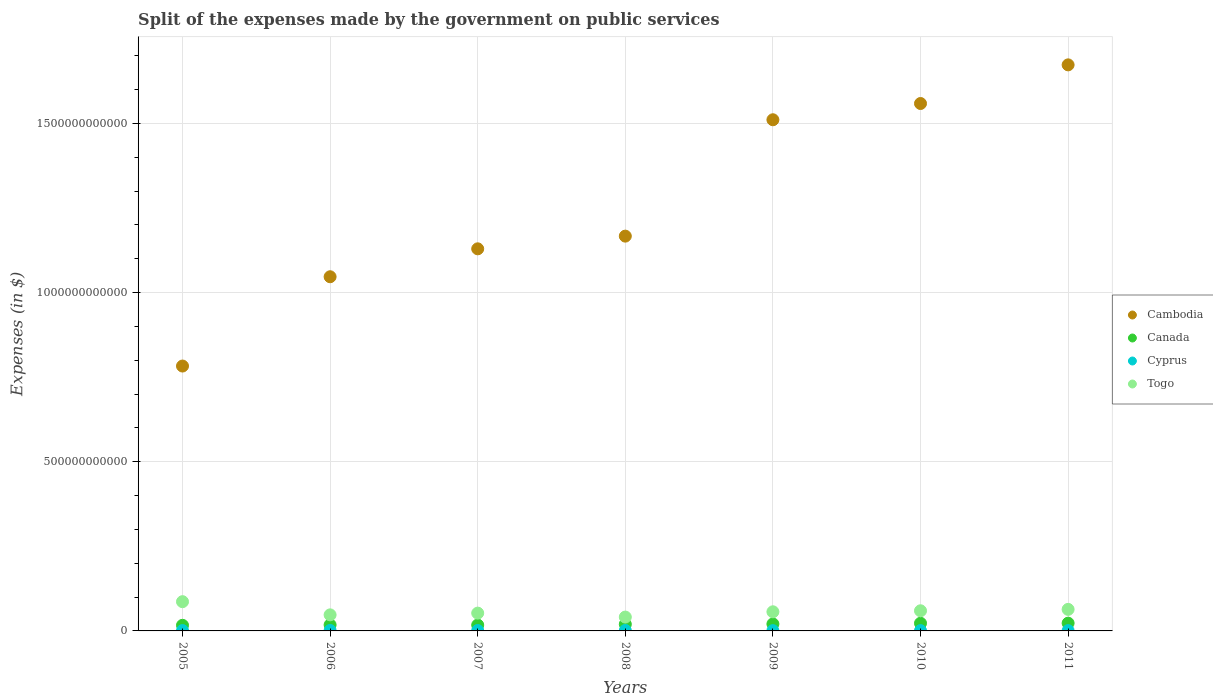Is the number of dotlines equal to the number of legend labels?
Offer a very short reply. Yes. What is the expenses made by the government on public services in Cyprus in 2010?
Make the answer very short. 8.91e+08. Across all years, what is the maximum expenses made by the government on public services in Canada?
Your response must be concise. 2.29e+1. Across all years, what is the minimum expenses made by the government on public services in Cambodia?
Offer a terse response. 7.83e+11. What is the total expenses made by the government on public services in Cambodia in the graph?
Make the answer very short. 8.87e+12. What is the difference between the expenses made by the government on public services in Cyprus in 2005 and that in 2006?
Keep it short and to the point. -2.13e+08. What is the difference between the expenses made by the government on public services in Canada in 2006 and the expenses made by the government on public services in Cyprus in 2005?
Your answer should be very brief. 1.68e+1. What is the average expenses made by the government on public services in Cambodia per year?
Offer a very short reply. 1.27e+12. In the year 2009, what is the difference between the expenses made by the government on public services in Togo and expenses made by the government on public services in Canada?
Ensure brevity in your answer.  3.60e+1. What is the ratio of the expenses made by the government on public services in Togo in 2006 to that in 2009?
Provide a succinct answer. 0.84. Is the expenses made by the government on public services in Togo in 2008 less than that in 2009?
Provide a succinct answer. Yes. What is the difference between the highest and the second highest expenses made by the government on public services in Cyprus?
Offer a terse response. 7.07e+07. What is the difference between the highest and the lowest expenses made by the government on public services in Canada?
Your answer should be compact. 6.34e+09. In how many years, is the expenses made by the government on public services in Cambodia greater than the average expenses made by the government on public services in Cambodia taken over all years?
Your answer should be compact. 3. Does the expenses made by the government on public services in Cyprus monotonically increase over the years?
Your answer should be compact. No. How many years are there in the graph?
Provide a succinct answer. 7. What is the difference between two consecutive major ticks on the Y-axis?
Give a very brief answer. 5.00e+11. Does the graph contain grids?
Offer a terse response. Yes. How many legend labels are there?
Your response must be concise. 4. How are the legend labels stacked?
Offer a very short reply. Vertical. What is the title of the graph?
Your response must be concise. Split of the expenses made by the government on public services. Does "Upper middle income" appear as one of the legend labels in the graph?
Offer a very short reply. No. What is the label or title of the Y-axis?
Provide a short and direct response. Expenses (in $). What is the Expenses (in $) in Cambodia in 2005?
Your answer should be very brief. 7.83e+11. What is the Expenses (in $) in Canada in 2005?
Your answer should be very brief. 1.66e+1. What is the Expenses (in $) in Cyprus in 2005?
Offer a very short reply. 1.05e+09. What is the Expenses (in $) of Togo in 2005?
Your response must be concise. 8.64e+1. What is the Expenses (in $) of Cambodia in 2006?
Give a very brief answer. 1.05e+12. What is the Expenses (in $) of Canada in 2006?
Ensure brevity in your answer.  1.79e+1. What is the Expenses (in $) of Cyprus in 2006?
Offer a very short reply. 1.26e+09. What is the Expenses (in $) of Togo in 2006?
Provide a succinct answer. 4.75e+1. What is the Expenses (in $) in Cambodia in 2007?
Your answer should be very brief. 1.13e+12. What is the Expenses (in $) in Canada in 2007?
Give a very brief answer. 1.74e+1. What is the Expenses (in $) in Cyprus in 2007?
Your response must be concise. 1.17e+09. What is the Expenses (in $) of Togo in 2007?
Give a very brief answer. 5.26e+1. What is the Expenses (in $) of Cambodia in 2008?
Your response must be concise. 1.17e+12. What is the Expenses (in $) of Canada in 2008?
Provide a short and direct response. 1.97e+1. What is the Expenses (in $) of Cyprus in 2008?
Provide a succinct answer. 1.33e+09. What is the Expenses (in $) of Togo in 2008?
Provide a succinct answer. 4.09e+1. What is the Expenses (in $) of Cambodia in 2009?
Your response must be concise. 1.51e+12. What is the Expenses (in $) in Canada in 2009?
Ensure brevity in your answer.  2.05e+1. What is the Expenses (in $) of Cyprus in 2009?
Make the answer very short. 8.23e+08. What is the Expenses (in $) in Togo in 2009?
Give a very brief answer. 5.65e+1. What is the Expenses (in $) in Cambodia in 2010?
Your answer should be very brief. 1.56e+12. What is the Expenses (in $) of Canada in 2010?
Keep it short and to the point. 2.27e+1. What is the Expenses (in $) in Cyprus in 2010?
Provide a succinct answer. 8.91e+08. What is the Expenses (in $) of Togo in 2010?
Offer a very short reply. 5.95e+1. What is the Expenses (in $) of Cambodia in 2011?
Provide a short and direct response. 1.67e+12. What is the Expenses (in $) of Canada in 2011?
Provide a short and direct response. 2.29e+1. What is the Expenses (in $) in Cyprus in 2011?
Your answer should be compact. 8.55e+08. What is the Expenses (in $) of Togo in 2011?
Provide a succinct answer. 6.37e+1. Across all years, what is the maximum Expenses (in $) of Cambodia?
Keep it short and to the point. 1.67e+12. Across all years, what is the maximum Expenses (in $) of Canada?
Keep it short and to the point. 2.29e+1. Across all years, what is the maximum Expenses (in $) in Cyprus?
Offer a terse response. 1.33e+09. Across all years, what is the maximum Expenses (in $) of Togo?
Your response must be concise. 8.64e+1. Across all years, what is the minimum Expenses (in $) in Cambodia?
Offer a terse response. 7.83e+11. Across all years, what is the minimum Expenses (in $) in Canada?
Provide a short and direct response. 1.66e+1. Across all years, what is the minimum Expenses (in $) in Cyprus?
Ensure brevity in your answer.  8.23e+08. Across all years, what is the minimum Expenses (in $) in Togo?
Your answer should be compact. 4.09e+1. What is the total Expenses (in $) of Cambodia in the graph?
Offer a very short reply. 8.87e+12. What is the total Expenses (in $) in Canada in the graph?
Offer a terse response. 1.38e+11. What is the total Expenses (in $) of Cyprus in the graph?
Your answer should be compact. 7.39e+09. What is the total Expenses (in $) of Togo in the graph?
Offer a very short reply. 4.07e+11. What is the difference between the Expenses (in $) of Cambodia in 2005 and that in 2006?
Provide a short and direct response. -2.64e+11. What is the difference between the Expenses (in $) in Canada in 2005 and that in 2006?
Provide a short and direct response. -1.26e+09. What is the difference between the Expenses (in $) of Cyprus in 2005 and that in 2006?
Give a very brief answer. -2.13e+08. What is the difference between the Expenses (in $) in Togo in 2005 and that in 2006?
Provide a short and direct response. 3.90e+1. What is the difference between the Expenses (in $) in Cambodia in 2005 and that in 2007?
Your response must be concise. -3.46e+11. What is the difference between the Expenses (in $) in Canada in 2005 and that in 2007?
Offer a very short reply. -7.98e+08. What is the difference between the Expenses (in $) in Cyprus in 2005 and that in 2007?
Ensure brevity in your answer.  -1.21e+08. What is the difference between the Expenses (in $) in Togo in 2005 and that in 2007?
Offer a terse response. 3.38e+1. What is the difference between the Expenses (in $) of Cambodia in 2005 and that in 2008?
Your answer should be very brief. -3.84e+11. What is the difference between the Expenses (in $) in Canada in 2005 and that in 2008?
Keep it short and to the point. -3.12e+09. What is the difference between the Expenses (in $) of Cyprus in 2005 and that in 2008?
Keep it short and to the point. -2.83e+08. What is the difference between the Expenses (in $) in Togo in 2005 and that in 2008?
Offer a very short reply. 4.55e+1. What is the difference between the Expenses (in $) of Cambodia in 2005 and that in 2009?
Keep it short and to the point. -7.28e+11. What is the difference between the Expenses (in $) of Canada in 2005 and that in 2009?
Your answer should be very brief. -3.93e+09. What is the difference between the Expenses (in $) in Cyprus in 2005 and that in 2009?
Keep it short and to the point. 2.27e+08. What is the difference between the Expenses (in $) in Togo in 2005 and that in 2009?
Make the answer very short. 2.99e+1. What is the difference between the Expenses (in $) of Cambodia in 2005 and that in 2010?
Your answer should be compact. -7.76e+11. What is the difference between the Expenses (in $) of Canada in 2005 and that in 2010?
Offer a very short reply. -6.07e+09. What is the difference between the Expenses (in $) of Cyprus in 2005 and that in 2010?
Offer a very short reply. 1.60e+08. What is the difference between the Expenses (in $) of Togo in 2005 and that in 2010?
Give a very brief answer. 2.69e+1. What is the difference between the Expenses (in $) of Cambodia in 2005 and that in 2011?
Your answer should be very brief. -8.90e+11. What is the difference between the Expenses (in $) of Canada in 2005 and that in 2011?
Your answer should be compact. -6.34e+09. What is the difference between the Expenses (in $) of Cyprus in 2005 and that in 2011?
Your response must be concise. 1.95e+08. What is the difference between the Expenses (in $) in Togo in 2005 and that in 2011?
Make the answer very short. 2.28e+1. What is the difference between the Expenses (in $) of Cambodia in 2006 and that in 2007?
Your response must be concise. -8.25e+1. What is the difference between the Expenses (in $) of Canada in 2006 and that in 2007?
Your answer should be very brief. 4.67e+08. What is the difference between the Expenses (in $) of Cyprus in 2006 and that in 2007?
Your response must be concise. 9.14e+07. What is the difference between the Expenses (in $) in Togo in 2006 and that in 2007?
Offer a very short reply. -5.13e+09. What is the difference between the Expenses (in $) in Cambodia in 2006 and that in 2008?
Your answer should be very brief. -1.20e+11. What is the difference between the Expenses (in $) in Canada in 2006 and that in 2008?
Keep it short and to the point. -1.85e+09. What is the difference between the Expenses (in $) in Cyprus in 2006 and that in 2008?
Give a very brief answer. -7.07e+07. What is the difference between the Expenses (in $) of Togo in 2006 and that in 2008?
Provide a succinct answer. 6.54e+09. What is the difference between the Expenses (in $) in Cambodia in 2006 and that in 2009?
Ensure brevity in your answer.  -4.64e+11. What is the difference between the Expenses (in $) of Canada in 2006 and that in 2009?
Offer a terse response. -2.66e+09. What is the difference between the Expenses (in $) of Cyprus in 2006 and that in 2009?
Provide a succinct answer. 4.40e+08. What is the difference between the Expenses (in $) in Togo in 2006 and that in 2009?
Your answer should be very brief. -9.06e+09. What is the difference between the Expenses (in $) in Cambodia in 2006 and that in 2010?
Provide a succinct answer. -5.12e+11. What is the difference between the Expenses (in $) in Canada in 2006 and that in 2010?
Keep it short and to the point. -4.80e+09. What is the difference between the Expenses (in $) in Cyprus in 2006 and that in 2010?
Ensure brevity in your answer.  3.72e+08. What is the difference between the Expenses (in $) in Togo in 2006 and that in 2010?
Provide a short and direct response. -1.21e+1. What is the difference between the Expenses (in $) of Cambodia in 2006 and that in 2011?
Ensure brevity in your answer.  -6.26e+11. What is the difference between the Expenses (in $) of Canada in 2006 and that in 2011?
Your answer should be very brief. -5.07e+09. What is the difference between the Expenses (in $) in Cyprus in 2006 and that in 2011?
Provide a succinct answer. 4.08e+08. What is the difference between the Expenses (in $) in Togo in 2006 and that in 2011?
Provide a succinct answer. -1.62e+1. What is the difference between the Expenses (in $) in Cambodia in 2007 and that in 2008?
Your response must be concise. -3.75e+1. What is the difference between the Expenses (in $) of Canada in 2007 and that in 2008?
Your response must be concise. -2.32e+09. What is the difference between the Expenses (in $) of Cyprus in 2007 and that in 2008?
Ensure brevity in your answer.  -1.62e+08. What is the difference between the Expenses (in $) of Togo in 2007 and that in 2008?
Your answer should be very brief. 1.17e+1. What is the difference between the Expenses (in $) of Cambodia in 2007 and that in 2009?
Ensure brevity in your answer.  -3.81e+11. What is the difference between the Expenses (in $) in Canada in 2007 and that in 2009?
Keep it short and to the point. -3.13e+09. What is the difference between the Expenses (in $) in Cyprus in 2007 and that in 2009?
Your answer should be very brief. 3.48e+08. What is the difference between the Expenses (in $) of Togo in 2007 and that in 2009?
Your answer should be very brief. -3.92e+09. What is the difference between the Expenses (in $) of Cambodia in 2007 and that in 2010?
Offer a terse response. -4.30e+11. What is the difference between the Expenses (in $) in Canada in 2007 and that in 2010?
Offer a terse response. -5.27e+09. What is the difference between the Expenses (in $) in Cyprus in 2007 and that in 2010?
Your answer should be very brief. 2.81e+08. What is the difference between the Expenses (in $) of Togo in 2007 and that in 2010?
Offer a terse response. -6.92e+09. What is the difference between the Expenses (in $) in Cambodia in 2007 and that in 2011?
Offer a terse response. -5.44e+11. What is the difference between the Expenses (in $) in Canada in 2007 and that in 2011?
Make the answer very short. -5.54e+09. What is the difference between the Expenses (in $) in Cyprus in 2007 and that in 2011?
Your answer should be very brief. 3.16e+08. What is the difference between the Expenses (in $) in Togo in 2007 and that in 2011?
Make the answer very short. -1.11e+1. What is the difference between the Expenses (in $) in Cambodia in 2008 and that in 2009?
Your response must be concise. -3.44e+11. What is the difference between the Expenses (in $) in Canada in 2008 and that in 2009?
Provide a short and direct response. -8.08e+08. What is the difference between the Expenses (in $) in Cyprus in 2008 and that in 2009?
Keep it short and to the point. 5.10e+08. What is the difference between the Expenses (in $) in Togo in 2008 and that in 2009?
Ensure brevity in your answer.  -1.56e+1. What is the difference between the Expenses (in $) of Cambodia in 2008 and that in 2010?
Give a very brief answer. -3.92e+11. What is the difference between the Expenses (in $) of Canada in 2008 and that in 2010?
Provide a short and direct response. -2.95e+09. What is the difference between the Expenses (in $) in Cyprus in 2008 and that in 2010?
Ensure brevity in your answer.  4.43e+08. What is the difference between the Expenses (in $) in Togo in 2008 and that in 2010?
Your answer should be very brief. -1.86e+1. What is the difference between the Expenses (in $) in Cambodia in 2008 and that in 2011?
Your answer should be compact. -5.06e+11. What is the difference between the Expenses (in $) in Canada in 2008 and that in 2011?
Your response must be concise. -3.22e+09. What is the difference between the Expenses (in $) of Cyprus in 2008 and that in 2011?
Provide a succinct answer. 4.79e+08. What is the difference between the Expenses (in $) in Togo in 2008 and that in 2011?
Ensure brevity in your answer.  -2.27e+1. What is the difference between the Expenses (in $) in Cambodia in 2009 and that in 2010?
Offer a terse response. -4.80e+1. What is the difference between the Expenses (in $) in Canada in 2009 and that in 2010?
Give a very brief answer. -2.14e+09. What is the difference between the Expenses (in $) in Cyprus in 2009 and that in 2010?
Make the answer very short. -6.76e+07. What is the difference between the Expenses (in $) in Togo in 2009 and that in 2010?
Offer a terse response. -2.99e+09. What is the difference between the Expenses (in $) of Cambodia in 2009 and that in 2011?
Offer a terse response. -1.62e+11. What is the difference between the Expenses (in $) in Canada in 2009 and that in 2011?
Keep it short and to the point. -2.41e+09. What is the difference between the Expenses (in $) of Cyprus in 2009 and that in 2011?
Offer a terse response. -3.18e+07. What is the difference between the Expenses (in $) in Togo in 2009 and that in 2011?
Your answer should be compact. -7.14e+09. What is the difference between the Expenses (in $) in Cambodia in 2010 and that in 2011?
Offer a very short reply. -1.14e+11. What is the difference between the Expenses (in $) of Canada in 2010 and that in 2011?
Ensure brevity in your answer.  -2.67e+08. What is the difference between the Expenses (in $) in Cyprus in 2010 and that in 2011?
Ensure brevity in your answer.  3.58e+07. What is the difference between the Expenses (in $) in Togo in 2010 and that in 2011?
Keep it short and to the point. -4.14e+09. What is the difference between the Expenses (in $) in Cambodia in 2005 and the Expenses (in $) in Canada in 2006?
Give a very brief answer. 7.65e+11. What is the difference between the Expenses (in $) of Cambodia in 2005 and the Expenses (in $) of Cyprus in 2006?
Offer a very short reply. 7.82e+11. What is the difference between the Expenses (in $) of Cambodia in 2005 and the Expenses (in $) of Togo in 2006?
Your answer should be very brief. 7.35e+11. What is the difference between the Expenses (in $) of Canada in 2005 and the Expenses (in $) of Cyprus in 2006?
Ensure brevity in your answer.  1.53e+1. What is the difference between the Expenses (in $) in Canada in 2005 and the Expenses (in $) in Togo in 2006?
Provide a succinct answer. -3.09e+1. What is the difference between the Expenses (in $) in Cyprus in 2005 and the Expenses (in $) in Togo in 2006?
Offer a terse response. -4.64e+1. What is the difference between the Expenses (in $) in Cambodia in 2005 and the Expenses (in $) in Canada in 2007?
Keep it short and to the point. 7.66e+11. What is the difference between the Expenses (in $) of Cambodia in 2005 and the Expenses (in $) of Cyprus in 2007?
Make the answer very short. 7.82e+11. What is the difference between the Expenses (in $) in Cambodia in 2005 and the Expenses (in $) in Togo in 2007?
Offer a terse response. 7.30e+11. What is the difference between the Expenses (in $) in Canada in 2005 and the Expenses (in $) in Cyprus in 2007?
Your answer should be compact. 1.54e+1. What is the difference between the Expenses (in $) of Canada in 2005 and the Expenses (in $) of Togo in 2007?
Make the answer very short. -3.60e+1. What is the difference between the Expenses (in $) in Cyprus in 2005 and the Expenses (in $) in Togo in 2007?
Make the answer very short. -5.16e+1. What is the difference between the Expenses (in $) in Cambodia in 2005 and the Expenses (in $) in Canada in 2008?
Keep it short and to the point. 7.63e+11. What is the difference between the Expenses (in $) of Cambodia in 2005 and the Expenses (in $) of Cyprus in 2008?
Your answer should be very brief. 7.82e+11. What is the difference between the Expenses (in $) of Cambodia in 2005 and the Expenses (in $) of Togo in 2008?
Your answer should be very brief. 7.42e+11. What is the difference between the Expenses (in $) in Canada in 2005 and the Expenses (in $) in Cyprus in 2008?
Offer a very short reply. 1.53e+1. What is the difference between the Expenses (in $) of Canada in 2005 and the Expenses (in $) of Togo in 2008?
Offer a very short reply. -2.43e+1. What is the difference between the Expenses (in $) of Cyprus in 2005 and the Expenses (in $) of Togo in 2008?
Ensure brevity in your answer.  -3.99e+1. What is the difference between the Expenses (in $) of Cambodia in 2005 and the Expenses (in $) of Canada in 2009?
Your response must be concise. 7.62e+11. What is the difference between the Expenses (in $) of Cambodia in 2005 and the Expenses (in $) of Cyprus in 2009?
Offer a very short reply. 7.82e+11. What is the difference between the Expenses (in $) of Cambodia in 2005 and the Expenses (in $) of Togo in 2009?
Your answer should be very brief. 7.26e+11. What is the difference between the Expenses (in $) in Canada in 2005 and the Expenses (in $) in Cyprus in 2009?
Provide a succinct answer. 1.58e+1. What is the difference between the Expenses (in $) of Canada in 2005 and the Expenses (in $) of Togo in 2009?
Provide a succinct answer. -3.99e+1. What is the difference between the Expenses (in $) of Cyprus in 2005 and the Expenses (in $) of Togo in 2009?
Give a very brief answer. -5.55e+1. What is the difference between the Expenses (in $) in Cambodia in 2005 and the Expenses (in $) in Canada in 2010?
Provide a short and direct response. 7.60e+11. What is the difference between the Expenses (in $) of Cambodia in 2005 and the Expenses (in $) of Cyprus in 2010?
Keep it short and to the point. 7.82e+11. What is the difference between the Expenses (in $) of Cambodia in 2005 and the Expenses (in $) of Togo in 2010?
Your response must be concise. 7.23e+11. What is the difference between the Expenses (in $) of Canada in 2005 and the Expenses (in $) of Cyprus in 2010?
Make the answer very short. 1.57e+1. What is the difference between the Expenses (in $) in Canada in 2005 and the Expenses (in $) in Togo in 2010?
Provide a short and direct response. -4.29e+1. What is the difference between the Expenses (in $) of Cyprus in 2005 and the Expenses (in $) of Togo in 2010?
Ensure brevity in your answer.  -5.85e+1. What is the difference between the Expenses (in $) of Cambodia in 2005 and the Expenses (in $) of Canada in 2011?
Give a very brief answer. 7.60e+11. What is the difference between the Expenses (in $) of Cambodia in 2005 and the Expenses (in $) of Cyprus in 2011?
Ensure brevity in your answer.  7.82e+11. What is the difference between the Expenses (in $) of Cambodia in 2005 and the Expenses (in $) of Togo in 2011?
Offer a terse response. 7.19e+11. What is the difference between the Expenses (in $) of Canada in 2005 and the Expenses (in $) of Cyprus in 2011?
Make the answer very short. 1.57e+1. What is the difference between the Expenses (in $) of Canada in 2005 and the Expenses (in $) of Togo in 2011?
Your response must be concise. -4.71e+1. What is the difference between the Expenses (in $) of Cyprus in 2005 and the Expenses (in $) of Togo in 2011?
Provide a short and direct response. -6.26e+1. What is the difference between the Expenses (in $) of Cambodia in 2006 and the Expenses (in $) of Canada in 2007?
Provide a succinct answer. 1.03e+12. What is the difference between the Expenses (in $) in Cambodia in 2006 and the Expenses (in $) in Cyprus in 2007?
Offer a terse response. 1.05e+12. What is the difference between the Expenses (in $) of Cambodia in 2006 and the Expenses (in $) of Togo in 2007?
Your answer should be very brief. 9.94e+11. What is the difference between the Expenses (in $) of Canada in 2006 and the Expenses (in $) of Cyprus in 2007?
Offer a very short reply. 1.67e+1. What is the difference between the Expenses (in $) of Canada in 2006 and the Expenses (in $) of Togo in 2007?
Offer a terse response. -3.48e+1. What is the difference between the Expenses (in $) of Cyprus in 2006 and the Expenses (in $) of Togo in 2007?
Ensure brevity in your answer.  -5.14e+1. What is the difference between the Expenses (in $) of Cambodia in 2006 and the Expenses (in $) of Canada in 2008?
Your response must be concise. 1.03e+12. What is the difference between the Expenses (in $) of Cambodia in 2006 and the Expenses (in $) of Cyprus in 2008?
Provide a succinct answer. 1.05e+12. What is the difference between the Expenses (in $) of Cambodia in 2006 and the Expenses (in $) of Togo in 2008?
Offer a very short reply. 1.01e+12. What is the difference between the Expenses (in $) in Canada in 2006 and the Expenses (in $) in Cyprus in 2008?
Your answer should be compact. 1.65e+1. What is the difference between the Expenses (in $) of Canada in 2006 and the Expenses (in $) of Togo in 2008?
Provide a succinct answer. -2.31e+1. What is the difference between the Expenses (in $) in Cyprus in 2006 and the Expenses (in $) in Togo in 2008?
Provide a succinct answer. -3.97e+1. What is the difference between the Expenses (in $) of Cambodia in 2006 and the Expenses (in $) of Canada in 2009?
Ensure brevity in your answer.  1.03e+12. What is the difference between the Expenses (in $) of Cambodia in 2006 and the Expenses (in $) of Cyprus in 2009?
Provide a succinct answer. 1.05e+12. What is the difference between the Expenses (in $) of Cambodia in 2006 and the Expenses (in $) of Togo in 2009?
Your response must be concise. 9.90e+11. What is the difference between the Expenses (in $) in Canada in 2006 and the Expenses (in $) in Cyprus in 2009?
Your answer should be very brief. 1.70e+1. What is the difference between the Expenses (in $) in Canada in 2006 and the Expenses (in $) in Togo in 2009?
Ensure brevity in your answer.  -3.87e+1. What is the difference between the Expenses (in $) of Cyprus in 2006 and the Expenses (in $) of Togo in 2009?
Give a very brief answer. -5.53e+1. What is the difference between the Expenses (in $) in Cambodia in 2006 and the Expenses (in $) in Canada in 2010?
Make the answer very short. 1.02e+12. What is the difference between the Expenses (in $) of Cambodia in 2006 and the Expenses (in $) of Cyprus in 2010?
Offer a very short reply. 1.05e+12. What is the difference between the Expenses (in $) of Cambodia in 2006 and the Expenses (in $) of Togo in 2010?
Your answer should be very brief. 9.87e+11. What is the difference between the Expenses (in $) of Canada in 2006 and the Expenses (in $) of Cyprus in 2010?
Your response must be concise. 1.70e+1. What is the difference between the Expenses (in $) of Canada in 2006 and the Expenses (in $) of Togo in 2010?
Your answer should be compact. -4.17e+1. What is the difference between the Expenses (in $) in Cyprus in 2006 and the Expenses (in $) in Togo in 2010?
Provide a succinct answer. -5.83e+1. What is the difference between the Expenses (in $) in Cambodia in 2006 and the Expenses (in $) in Canada in 2011?
Offer a terse response. 1.02e+12. What is the difference between the Expenses (in $) in Cambodia in 2006 and the Expenses (in $) in Cyprus in 2011?
Keep it short and to the point. 1.05e+12. What is the difference between the Expenses (in $) in Cambodia in 2006 and the Expenses (in $) in Togo in 2011?
Offer a very short reply. 9.83e+11. What is the difference between the Expenses (in $) in Canada in 2006 and the Expenses (in $) in Cyprus in 2011?
Offer a very short reply. 1.70e+1. What is the difference between the Expenses (in $) in Canada in 2006 and the Expenses (in $) in Togo in 2011?
Provide a short and direct response. -4.58e+1. What is the difference between the Expenses (in $) in Cyprus in 2006 and the Expenses (in $) in Togo in 2011?
Offer a very short reply. -6.24e+1. What is the difference between the Expenses (in $) of Cambodia in 2007 and the Expenses (in $) of Canada in 2008?
Provide a short and direct response. 1.11e+12. What is the difference between the Expenses (in $) of Cambodia in 2007 and the Expenses (in $) of Cyprus in 2008?
Offer a terse response. 1.13e+12. What is the difference between the Expenses (in $) in Cambodia in 2007 and the Expenses (in $) in Togo in 2008?
Make the answer very short. 1.09e+12. What is the difference between the Expenses (in $) in Canada in 2007 and the Expenses (in $) in Cyprus in 2008?
Make the answer very short. 1.61e+1. What is the difference between the Expenses (in $) in Canada in 2007 and the Expenses (in $) in Togo in 2008?
Make the answer very short. -2.35e+1. What is the difference between the Expenses (in $) in Cyprus in 2007 and the Expenses (in $) in Togo in 2008?
Provide a succinct answer. -3.98e+1. What is the difference between the Expenses (in $) of Cambodia in 2007 and the Expenses (in $) of Canada in 2009?
Keep it short and to the point. 1.11e+12. What is the difference between the Expenses (in $) of Cambodia in 2007 and the Expenses (in $) of Cyprus in 2009?
Provide a short and direct response. 1.13e+12. What is the difference between the Expenses (in $) of Cambodia in 2007 and the Expenses (in $) of Togo in 2009?
Provide a short and direct response. 1.07e+12. What is the difference between the Expenses (in $) in Canada in 2007 and the Expenses (in $) in Cyprus in 2009?
Offer a terse response. 1.66e+1. What is the difference between the Expenses (in $) in Canada in 2007 and the Expenses (in $) in Togo in 2009?
Provide a short and direct response. -3.91e+1. What is the difference between the Expenses (in $) of Cyprus in 2007 and the Expenses (in $) of Togo in 2009?
Make the answer very short. -5.54e+1. What is the difference between the Expenses (in $) of Cambodia in 2007 and the Expenses (in $) of Canada in 2010?
Make the answer very short. 1.11e+12. What is the difference between the Expenses (in $) of Cambodia in 2007 and the Expenses (in $) of Cyprus in 2010?
Provide a short and direct response. 1.13e+12. What is the difference between the Expenses (in $) of Cambodia in 2007 and the Expenses (in $) of Togo in 2010?
Provide a short and direct response. 1.07e+12. What is the difference between the Expenses (in $) in Canada in 2007 and the Expenses (in $) in Cyprus in 2010?
Provide a succinct answer. 1.65e+1. What is the difference between the Expenses (in $) of Canada in 2007 and the Expenses (in $) of Togo in 2010?
Keep it short and to the point. -4.21e+1. What is the difference between the Expenses (in $) in Cyprus in 2007 and the Expenses (in $) in Togo in 2010?
Your answer should be very brief. -5.84e+1. What is the difference between the Expenses (in $) of Cambodia in 2007 and the Expenses (in $) of Canada in 2011?
Keep it short and to the point. 1.11e+12. What is the difference between the Expenses (in $) of Cambodia in 2007 and the Expenses (in $) of Cyprus in 2011?
Offer a very short reply. 1.13e+12. What is the difference between the Expenses (in $) in Cambodia in 2007 and the Expenses (in $) in Togo in 2011?
Your answer should be compact. 1.07e+12. What is the difference between the Expenses (in $) in Canada in 2007 and the Expenses (in $) in Cyprus in 2011?
Offer a terse response. 1.65e+1. What is the difference between the Expenses (in $) of Canada in 2007 and the Expenses (in $) of Togo in 2011?
Provide a short and direct response. -4.63e+1. What is the difference between the Expenses (in $) of Cyprus in 2007 and the Expenses (in $) of Togo in 2011?
Provide a succinct answer. -6.25e+1. What is the difference between the Expenses (in $) in Cambodia in 2008 and the Expenses (in $) in Canada in 2009?
Offer a terse response. 1.15e+12. What is the difference between the Expenses (in $) in Cambodia in 2008 and the Expenses (in $) in Cyprus in 2009?
Your answer should be compact. 1.17e+12. What is the difference between the Expenses (in $) of Cambodia in 2008 and the Expenses (in $) of Togo in 2009?
Make the answer very short. 1.11e+12. What is the difference between the Expenses (in $) of Canada in 2008 and the Expenses (in $) of Cyprus in 2009?
Make the answer very short. 1.89e+1. What is the difference between the Expenses (in $) of Canada in 2008 and the Expenses (in $) of Togo in 2009?
Give a very brief answer. -3.68e+1. What is the difference between the Expenses (in $) of Cyprus in 2008 and the Expenses (in $) of Togo in 2009?
Your answer should be compact. -5.52e+1. What is the difference between the Expenses (in $) of Cambodia in 2008 and the Expenses (in $) of Canada in 2010?
Your answer should be very brief. 1.14e+12. What is the difference between the Expenses (in $) in Cambodia in 2008 and the Expenses (in $) in Cyprus in 2010?
Provide a short and direct response. 1.17e+12. What is the difference between the Expenses (in $) in Cambodia in 2008 and the Expenses (in $) in Togo in 2010?
Offer a very short reply. 1.11e+12. What is the difference between the Expenses (in $) of Canada in 2008 and the Expenses (in $) of Cyprus in 2010?
Provide a short and direct response. 1.88e+1. What is the difference between the Expenses (in $) of Canada in 2008 and the Expenses (in $) of Togo in 2010?
Keep it short and to the point. -3.98e+1. What is the difference between the Expenses (in $) of Cyprus in 2008 and the Expenses (in $) of Togo in 2010?
Your answer should be very brief. -5.82e+1. What is the difference between the Expenses (in $) in Cambodia in 2008 and the Expenses (in $) in Canada in 2011?
Your response must be concise. 1.14e+12. What is the difference between the Expenses (in $) in Cambodia in 2008 and the Expenses (in $) in Cyprus in 2011?
Provide a succinct answer. 1.17e+12. What is the difference between the Expenses (in $) of Cambodia in 2008 and the Expenses (in $) of Togo in 2011?
Offer a terse response. 1.10e+12. What is the difference between the Expenses (in $) of Canada in 2008 and the Expenses (in $) of Cyprus in 2011?
Offer a very short reply. 1.89e+1. What is the difference between the Expenses (in $) in Canada in 2008 and the Expenses (in $) in Togo in 2011?
Give a very brief answer. -4.40e+1. What is the difference between the Expenses (in $) in Cyprus in 2008 and the Expenses (in $) in Togo in 2011?
Offer a very short reply. -6.23e+1. What is the difference between the Expenses (in $) in Cambodia in 2009 and the Expenses (in $) in Canada in 2010?
Keep it short and to the point. 1.49e+12. What is the difference between the Expenses (in $) of Cambodia in 2009 and the Expenses (in $) of Cyprus in 2010?
Your response must be concise. 1.51e+12. What is the difference between the Expenses (in $) in Cambodia in 2009 and the Expenses (in $) in Togo in 2010?
Provide a short and direct response. 1.45e+12. What is the difference between the Expenses (in $) of Canada in 2009 and the Expenses (in $) of Cyprus in 2010?
Make the answer very short. 1.96e+1. What is the difference between the Expenses (in $) of Canada in 2009 and the Expenses (in $) of Togo in 2010?
Give a very brief answer. -3.90e+1. What is the difference between the Expenses (in $) in Cyprus in 2009 and the Expenses (in $) in Togo in 2010?
Offer a terse response. -5.87e+1. What is the difference between the Expenses (in $) of Cambodia in 2009 and the Expenses (in $) of Canada in 2011?
Ensure brevity in your answer.  1.49e+12. What is the difference between the Expenses (in $) of Cambodia in 2009 and the Expenses (in $) of Cyprus in 2011?
Give a very brief answer. 1.51e+12. What is the difference between the Expenses (in $) of Cambodia in 2009 and the Expenses (in $) of Togo in 2011?
Make the answer very short. 1.45e+12. What is the difference between the Expenses (in $) in Canada in 2009 and the Expenses (in $) in Cyprus in 2011?
Offer a very short reply. 1.97e+1. What is the difference between the Expenses (in $) of Canada in 2009 and the Expenses (in $) of Togo in 2011?
Ensure brevity in your answer.  -4.32e+1. What is the difference between the Expenses (in $) in Cyprus in 2009 and the Expenses (in $) in Togo in 2011?
Your answer should be compact. -6.29e+1. What is the difference between the Expenses (in $) in Cambodia in 2010 and the Expenses (in $) in Canada in 2011?
Your response must be concise. 1.54e+12. What is the difference between the Expenses (in $) in Cambodia in 2010 and the Expenses (in $) in Cyprus in 2011?
Your answer should be compact. 1.56e+12. What is the difference between the Expenses (in $) in Cambodia in 2010 and the Expenses (in $) in Togo in 2011?
Ensure brevity in your answer.  1.50e+12. What is the difference between the Expenses (in $) of Canada in 2010 and the Expenses (in $) of Cyprus in 2011?
Keep it short and to the point. 2.18e+1. What is the difference between the Expenses (in $) in Canada in 2010 and the Expenses (in $) in Togo in 2011?
Your answer should be very brief. -4.10e+1. What is the difference between the Expenses (in $) in Cyprus in 2010 and the Expenses (in $) in Togo in 2011?
Provide a short and direct response. -6.28e+1. What is the average Expenses (in $) in Cambodia per year?
Ensure brevity in your answer.  1.27e+12. What is the average Expenses (in $) of Canada per year?
Make the answer very short. 1.97e+1. What is the average Expenses (in $) in Cyprus per year?
Offer a terse response. 1.06e+09. What is the average Expenses (in $) in Togo per year?
Your answer should be very brief. 5.82e+1. In the year 2005, what is the difference between the Expenses (in $) in Cambodia and Expenses (in $) in Canada?
Make the answer very short. 7.66e+11. In the year 2005, what is the difference between the Expenses (in $) in Cambodia and Expenses (in $) in Cyprus?
Provide a succinct answer. 7.82e+11. In the year 2005, what is the difference between the Expenses (in $) of Cambodia and Expenses (in $) of Togo?
Keep it short and to the point. 6.97e+11. In the year 2005, what is the difference between the Expenses (in $) of Canada and Expenses (in $) of Cyprus?
Provide a succinct answer. 1.56e+1. In the year 2005, what is the difference between the Expenses (in $) of Canada and Expenses (in $) of Togo?
Your answer should be compact. -6.98e+1. In the year 2005, what is the difference between the Expenses (in $) in Cyprus and Expenses (in $) in Togo?
Offer a very short reply. -8.54e+1. In the year 2006, what is the difference between the Expenses (in $) in Cambodia and Expenses (in $) in Canada?
Keep it short and to the point. 1.03e+12. In the year 2006, what is the difference between the Expenses (in $) in Cambodia and Expenses (in $) in Cyprus?
Give a very brief answer. 1.05e+12. In the year 2006, what is the difference between the Expenses (in $) in Cambodia and Expenses (in $) in Togo?
Your answer should be compact. 9.99e+11. In the year 2006, what is the difference between the Expenses (in $) of Canada and Expenses (in $) of Cyprus?
Your answer should be compact. 1.66e+1. In the year 2006, what is the difference between the Expenses (in $) of Canada and Expenses (in $) of Togo?
Offer a very short reply. -2.96e+1. In the year 2006, what is the difference between the Expenses (in $) of Cyprus and Expenses (in $) of Togo?
Your answer should be compact. -4.62e+1. In the year 2007, what is the difference between the Expenses (in $) in Cambodia and Expenses (in $) in Canada?
Your answer should be very brief. 1.11e+12. In the year 2007, what is the difference between the Expenses (in $) of Cambodia and Expenses (in $) of Cyprus?
Your response must be concise. 1.13e+12. In the year 2007, what is the difference between the Expenses (in $) in Cambodia and Expenses (in $) in Togo?
Keep it short and to the point. 1.08e+12. In the year 2007, what is the difference between the Expenses (in $) in Canada and Expenses (in $) in Cyprus?
Offer a terse response. 1.62e+1. In the year 2007, what is the difference between the Expenses (in $) of Canada and Expenses (in $) of Togo?
Your response must be concise. -3.52e+1. In the year 2007, what is the difference between the Expenses (in $) of Cyprus and Expenses (in $) of Togo?
Your answer should be very brief. -5.14e+1. In the year 2008, what is the difference between the Expenses (in $) of Cambodia and Expenses (in $) of Canada?
Offer a very short reply. 1.15e+12. In the year 2008, what is the difference between the Expenses (in $) of Cambodia and Expenses (in $) of Cyprus?
Provide a short and direct response. 1.17e+12. In the year 2008, what is the difference between the Expenses (in $) in Cambodia and Expenses (in $) in Togo?
Your answer should be compact. 1.13e+12. In the year 2008, what is the difference between the Expenses (in $) in Canada and Expenses (in $) in Cyprus?
Provide a succinct answer. 1.84e+1. In the year 2008, what is the difference between the Expenses (in $) of Canada and Expenses (in $) of Togo?
Provide a succinct answer. -2.12e+1. In the year 2008, what is the difference between the Expenses (in $) of Cyprus and Expenses (in $) of Togo?
Provide a succinct answer. -3.96e+1. In the year 2009, what is the difference between the Expenses (in $) in Cambodia and Expenses (in $) in Canada?
Ensure brevity in your answer.  1.49e+12. In the year 2009, what is the difference between the Expenses (in $) in Cambodia and Expenses (in $) in Cyprus?
Your response must be concise. 1.51e+12. In the year 2009, what is the difference between the Expenses (in $) in Cambodia and Expenses (in $) in Togo?
Offer a very short reply. 1.45e+12. In the year 2009, what is the difference between the Expenses (in $) in Canada and Expenses (in $) in Cyprus?
Make the answer very short. 1.97e+1. In the year 2009, what is the difference between the Expenses (in $) in Canada and Expenses (in $) in Togo?
Provide a short and direct response. -3.60e+1. In the year 2009, what is the difference between the Expenses (in $) of Cyprus and Expenses (in $) of Togo?
Offer a very short reply. -5.57e+1. In the year 2010, what is the difference between the Expenses (in $) in Cambodia and Expenses (in $) in Canada?
Offer a terse response. 1.54e+12. In the year 2010, what is the difference between the Expenses (in $) in Cambodia and Expenses (in $) in Cyprus?
Provide a succinct answer. 1.56e+12. In the year 2010, what is the difference between the Expenses (in $) of Cambodia and Expenses (in $) of Togo?
Give a very brief answer. 1.50e+12. In the year 2010, what is the difference between the Expenses (in $) of Canada and Expenses (in $) of Cyprus?
Offer a terse response. 2.18e+1. In the year 2010, what is the difference between the Expenses (in $) in Canada and Expenses (in $) in Togo?
Make the answer very short. -3.69e+1. In the year 2010, what is the difference between the Expenses (in $) in Cyprus and Expenses (in $) in Togo?
Keep it short and to the point. -5.86e+1. In the year 2011, what is the difference between the Expenses (in $) of Cambodia and Expenses (in $) of Canada?
Your answer should be compact. 1.65e+12. In the year 2011, what is the difference between the Expenses (in $) in Cambodia and Expenses (in $) in Cyprus?
Ensure brevity in your answer.  1.67e+12. In the year 2011, what is the difference between the Expenses (in $) in Cambodia and Expenses (in $) in Togo?
Ensure brevity in your answer.  1.61e+12. In the year 2011, what is the difference between the Expenses (in $) in Canada and Expenses (in $) in Cyprus?
Your response must be concise. 2.21e+1. In the year 2011, what is the difference between the Expenses (in $) of Canada and Expenses (in $) of Togo?
Make the answer very short. -4.07e+1. In the year 2011, what is the difference between the Expenses (in $) of Cyprus and Expenses (in $) of Togo?
Give a very brief answer. -6.28e+1. What is the ratio of the Expenses (in $) of Cambodia in 2005 to that in 2006?
Keep it short and to the point. 0.75. What is the ratio of the Expenses (in $) in Canada in 2005 to that in 2006?
Make the answer very short. 0.93. What is the ratio of the Expenses (in $) of Cyprus in 2005 to that in 2006?
Give a very brief answer. 0.83. What is the ratio of the Expenses (in $) in Togo in 2005 to that in 2006?
Offer a terse response. 1.82. What is the ratio of the Expenses (in $) of Cambodia in 2005 to that in 2007?
Ensure brevity in your answer.  0.69. What is the ratio of the Expenses (in $) of Canada in 2005 to that in 2007?
Your answer should be compact. 0.95. What is the ratio of the Expenses (in $) in Cyprus in 2005 to that in 2007?
Provide a short and direct response. 0.9. What is the ratio of the Expenses (in $) of Togo in 2005 to that in 2007?
Give a very brief answer. 1.64. What is the ratio of the Expenses (in $) in Cambodia in 2005 to that in 2008?
Your answer should be compact. 0.67. What is the ratio of the Expenses (in $) in Canada in 2005 to that in 2008?
Offer a very short reply. 0.84. What is the ratio of the Expenses (in $) in Cyprus in 2005 to that in 2008?
Keep it short and to the point. 0.79. What is the ratio of the Expenses (in $) in Togo in 2005 to that in 2008?
Keep it short and to the point. 2.11. What is the ratio of the Expenses (in $) in Cambodia in 2005 to that in 2009?
Give a very brief answer. 0.52. What is the ratio of the Expenses (in $) of Canada in 2005 to that in 2009?
Make the answer very short. 0.81. What is the ratio of the Expenses (in $) in Cyprus in 2005 to that in 2009?
Your answer should be very brief. 1.28. What is the ratio of the Expenses (in $) in Togo in 2005 to that in 2009?
Offer a terse response. 1.53. What is the ratio of the Expenses (in $) of Cambodia in 2005 to that in 2010?
Provide a short and direct response. 0.5. What is the ratio of the Expenses (in $) in Canada in 2005 to that in 2010?
Offer a very short reply. 0.73. What is the ratio of the Expenses (in $) of Cyprus in 2005 to that in 2010?
Offer a very short reply. 1.18. What is the ratio of the Expenses (in $) of Togo in 2005 to that in 2010?
Give a very brief answer. 1.45. What is the ratio of the Expenses (in $) in Cambodia in 2005 to that in 2011?
Your answer should be very brief. 0.47. What is the ratio of the Expenses (in $) of Canada in 2005 to that in 2011?
Offer a terse response. 0.72. What is the ratio of the Expenses (in $) of Cyprus in 2005 to that in 2011?
Give a very brief answer. 1.23. What is the ratio of the Expenses (in $) in Togo in 2005 to that in 2011?
Your answer should be compact. 1.36. What is the ratio of the Expenses (in $) of Cambodia in 2006 to that in 2007?
Make the answer very short. 0.93. What is the ratio of the Expenses (in $) of Canada in 2006 to that in 2007?
Make the answer very short. 1.03. What is the ratio of the Expenses (in $) in Cyprus in 2006 to that in 2007?
Your answer should be compact. 1.08. What is the ratio of the Expenses (in $) in Togo in 2006 to that in 2007?
Give a very brief answer. 0.9. What is the ratio of the Expenses (in $) of Cambodia in 2006 to that in 2008?
Ensure brevity in your answer.  0.9. What is the ratio of the Expenses (in $) in Canada in 2006 to that in 2008?
Your answer should be very brief. 0.91. What is the ratio of the Expenses (in $) of Cyprus in 2006 to that in 2008?
Ensure brevity in your answer.  0.95. What is the ratio of the Expenses (in $) in Togo in 2006 to that in 2008?
Keep it short and to the point. 1.16. What is the ratio of the Expenses (in $) in Cambodia in 2006 to that in 2009?
Keep it short and to the point. 0.69. What is the ratio of the Expenses (in $) of Canada in 2006 to that in 2009?
Your answer should be compact. 0.87. What is the ratio of the Expenses (in $) in Cyprus in 2006 to that in 2009?
Your answer should be very brief. 1.53. What is the ratio of the Expenses (in $) of Togo in 2006 to that in 2009?
Your answer should be very brief. 0.84. What is the ratio of the Expenses (in $) of Cambodia in 2006 to that in 2010?
Give a very brief answer. 0.67. What is the ratio of the Expenses (in $) in Canada in 2006 to that in 2010?
Your answer should be compact. 0.79. What is the ratio of the Expenses (in $) in Cyprus in 2006 to that in 2010?
Your response must be concise. 1.42. What is the ratio of the Expenses (in $) in Togo in 2006 to that in 2010?
Provide a short and direct response. 0.8. What is the ratio of the Expenses (in $) in Cambodia in 2006 to that in 2011?
Your response must be concise. 0.63. What is the ratio of the Expenses (in $) in Canada in 2006 to that in 2011?
Give a very brief answer. 0.78. What is the ratio of the Expenses (in $) of Cyprus in 2006 to that in 2011?
Your response must be concise. 1.48. What is the ratio of the Expenses (in $) of Togo in 2006 to that in 2011?
Your answer should be compact. 0.75. What is the ratio of the Expenses (in $) of Cambodia in 2007 to that in 2008?
Ensure brevity in your answer.  0.97. What is the ratio of the Expenses (in $) in Canada in 2007 to that in 2008?
Provide a short and direct response. 0.88. What is the ratio of the Expenses (in $) of Cyprus in 2007 to that in 2008?
Give a very brief answer. 0.88. What is the ratio of the Expenses (in $) in Togo in 2007 to that in 2008?
Your response must be concise. 1.29. What is the ratio of the Expenses (in $) of Cambodia in 2007 to that in 2009?
Give a very brief answer. 0.75. What is the ratio of the Expenses (in $) in Canada in 2007 to that in 2009?
Make the answer very short. 0.85. What is the ratio of the Expenses (in $) of Cyprus in 2007 to that in 2009?
Give a very brief answer. 1.42. What is the ratio of the Expenses (in $) of Togo in 2007 to that in 2009?
Keep it short and to the point. 0.93. What is the ratio of the Expenses (in $) of Cambodia in 2007 to that in 2010?
Offer a very short reply. 0.72. What is the ratio of the Expenses (in $) in Canada in 2007 to that in 2010?
Ensure brevity in your answer.  0.77. What is the ratio of the Expenses (in $) of Cyprus in 2007 to that in 2010?
Offer a very short reply. 1.32. What is the ratio of the Expenses (in $) of Togo in 2007 to that in 2010?
Provide a short and direct response. 0.88. What is the ratio of the Expenses (in $) in Cambodia in 2007 to that in 2011?
Provide a short and direct response. 0.68. What is the ratio of the Expenses (in $) of Canada in 2007 to that in 2011?
Your answer should be compact. 0.76. What is the ratio of the Expenses (in $) in Cyprus in 2007 to that in 2011?
Keep it short and to the point. 1.37. What is the ratio of the Expenses (in $) of Togo in 2007 to that in 2011?
Give a very brief answer. 0.83. What is the ratio of the Expenses (in $) in Cambodia in 2008 to that in 2009?
Ensure brevity in your answer.  0.77. What is the ratio of the Expenses (in $) of Canada in 2008 to that in 2009?
Your answer should be compact. 0.96. What is the ratio of the Expenses (in $) in Cyprus in 2008 to that in 2009?
Your answer should be compact. 1.62. What is the ratio of the Expenses (in $) of Togo in 2008 to that in 2009?
Make the answer very short. 0.72. What is the ratio of the Expenses (in $) in Cambodia in 2008 to that in 2010?
Your answer should be very brief. 0.75. What is the ratio of the Expenses (in $) of Canada in 2008 to that in 2010?
Offer a terse response. 0.87. What is the ratio of the Expenses (in $) of Cyprus in 2008 to that in 2010?
Your answer should be very brief. 1.5. What is the ratio of the Expenses (in $) of Togo in 2008 to that in 2010?
Make the answer very short. 0.69. What is the ratio of the Expenses (in $) of Cambodia in 2008 to that in 2011?
Keep it short and to the point. 0.7. What is the ratio of the Expenses (in $) in Canada in 2008 to that in 2011?
Your answer should be compact. 0.86. What is the ratio of the Expenses (in $) of Cyprus in 2008 to that in 2011?
Provide a short and direct response. 1.56. What is the ratio of the Expenses (in $) in Togo in 2008 to that in 2011?
Your answer should be compact. 0.64. What is the ratio of the Expenses (in $) of Cambodia in 2009 to that in 2010?
Offer a very short reply. 0.97. What is the ratio of the Expenses (in $) in Canada in 2009 to that in 2010?
Provide a succinct answer. 0.91. What is the ratio of the Expenses (in $) of Cyprus in 2009 to that in 2010?
Offer a very short reply. 0.92. What is the ratio of the Expenses (in $) of Togo in 2009 to that in 2010?
Ensure brevity in your answer.  0.95. What is the ratio of the Expenses (in $) of Cambodia in 2009 to that in 2011?
Offer a very short reply. 0.9. What is the ratio of the Expenses (in $) in Canada in 2009 to that in 2011?
Offer a very short reply. 0.89. What is the ratio of the Expenses (in $) in Cyprus in 2009 to that in 2011?
Keep it short and to the point. 0.96. What is the ratio of the Expenses (in $) in Togo in 2009 to that in 2011?
Provide a succinct answer. 0.89. What is the ratio of the Expenses (in $) in Cambodia in 2010 to that in 2011?
Your response must be concise. 0.93. What is the ratio of the Expenses (in $) in Canada in 2010 to that in 2011?
Ensure brevity in your answer.  0.99. What is the ratio of the Expenses (in $) in Cyprus in 2010 to that in 2011?
Provide a succinct answer. 1.04. What is the ratio of the Expenses (in $) in Togo in 2010 to that in 2011?
Offer a terse response. 0.93. What is the difference between the highest and the second highest Expenses (in $) in Cambodia?
Make the answer very short. 1.14e+11. What is the difference between the highest and the second highest Expenses (in $) of Canada?
Your answer should be compact. 2.67e+08. What is the difference between the highest and the second highest Expenses (in $) in Cyprus?
Provide a short and direct response. 7.07e+07. What is the difference between the highest and the second highest Expenses (in $) in Togo?
Keep it short and to the point. 2.28e+1. What is the difference between the highest and the lowest Expenses (in $) of Cambodia?
Your answer should be very brief. 8.90e+11. What is the difference between the highest and the lowest Expenses (in $) of Canada?
Keep it short and to the point. 6.34e+09. What is the difference between the highest and the lowest Expenses (in $) in Cyprus?
Your answer should be very brief. 5.10e+08. What is the difference between the highest and the lowest Expenses (in $) of Togo?
Make the answer very short. 4.55e+1. 